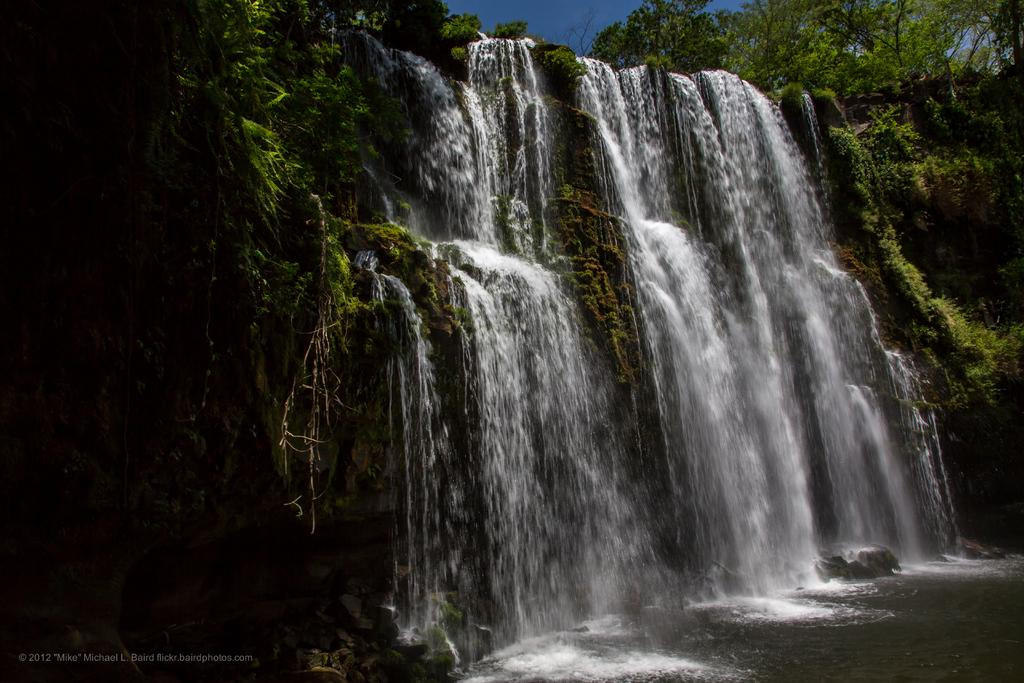What natural feature is present in the image? There are waterfalls in the image. What type of vegetation can be seen in the image? There are trees in the image. What is visible in the background of the image? The sky is visible in the image. What type of calendar is hanging on the tree in the image? There is no calendar present in the image; it features waterfalls, trees, and the sky. Can you tell me who won the argument in the image? There is no argument present in the image; it features waterfalls, trees, and the sky. 